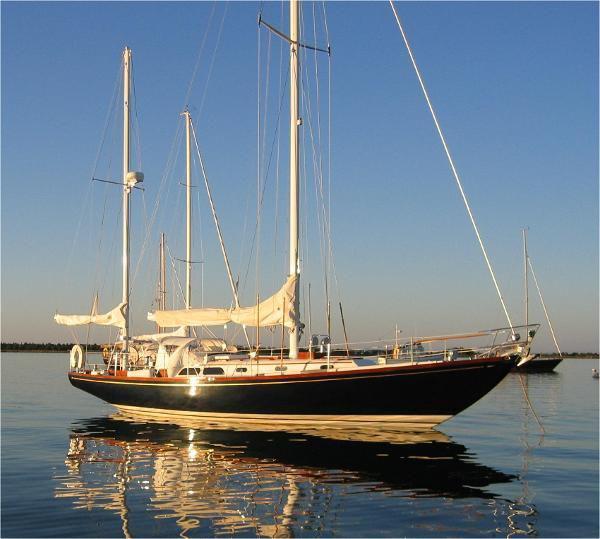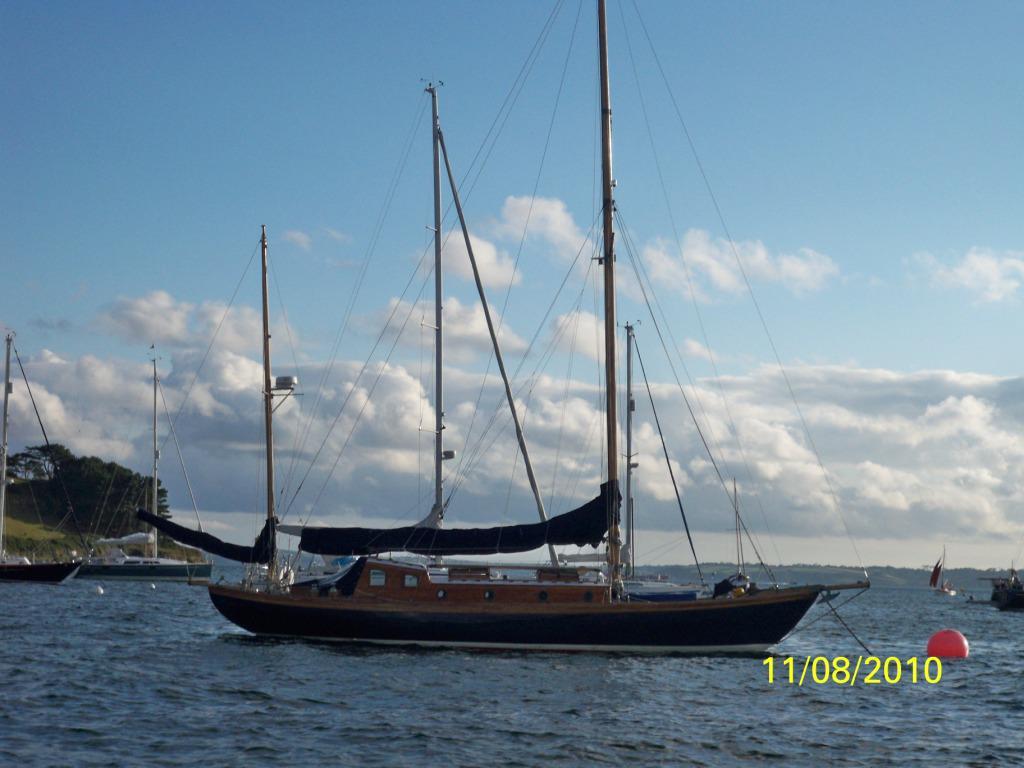The first image is the image on the left, the second image is the image on the right. Evaluate the accuracy of this statement regarding the images: "the sails are furled in the image on the right". Is it true? Answer yes or no. Yes. The first image is the image on the left, the second image is the image on the right. For the images shown, is this caption "All boat sails are furled." true? Answer yes or no. Yes. 